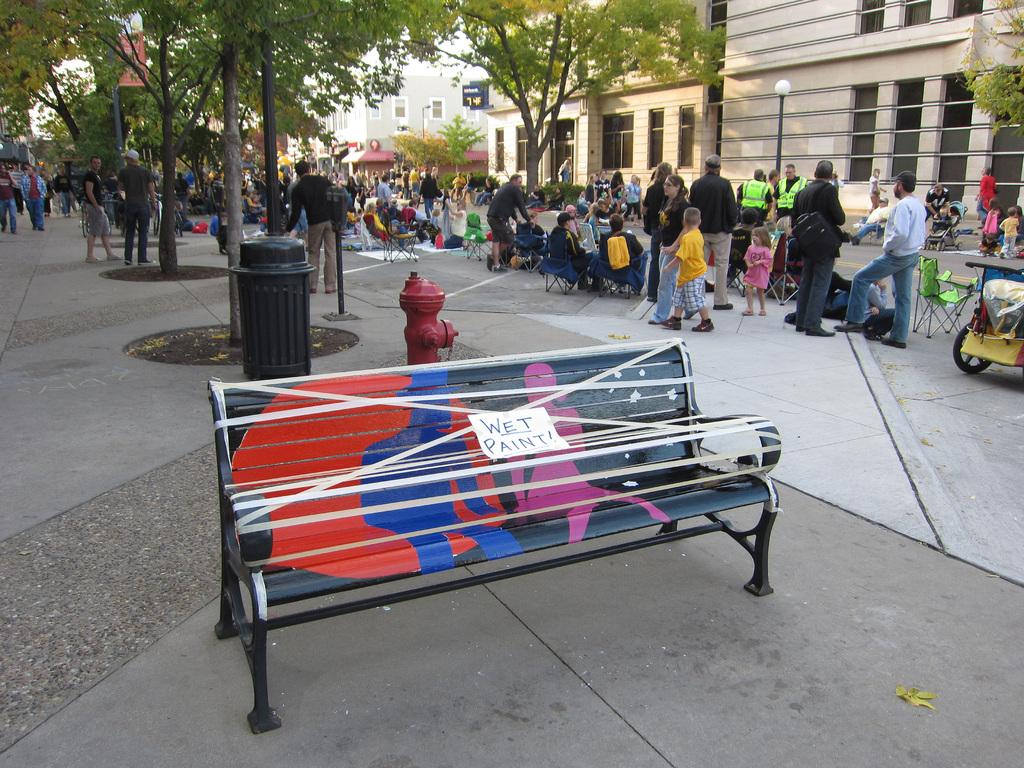How many people are in the image? There is a group of people in the image, but the exact number is not specified. What are the people in the image doing? Some people are sitting, while others are standing. What is the seating arrangement in the image? There is a bench in the image. What can be seen in the background of the image? There are buildings and trees visible in the image. What type of cheese is being served on the bench in the image? There is no cheese present in the image; it features a group of people with some sitting and others standing, along with a bench and background elements. 